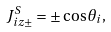<formula> <loc_0><loc_0><loc_500><loc_500>J _ { i z \pm } ^ { S } = \pm \cos \theta _ { i } ,</formula> 